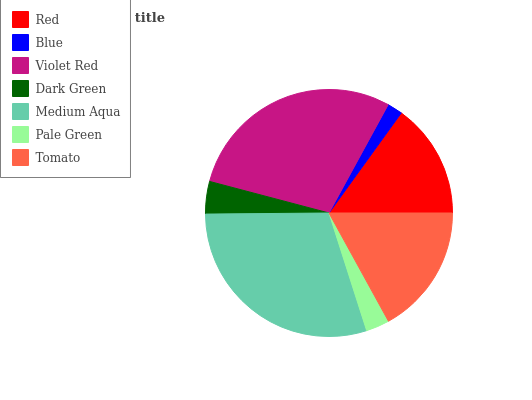Is Blue the minimum?
Answer yes or no. Yes. Is Medium Aqua the maximum?
Answer yes or no. Yes. Is Violet Red the minimum?
Answer yes or no. No. Is Violet Red the maximum?
Answer yes or no. No. Is Violet Red greater than Blue?
Answer yes or no. Yes. Is Blue less than Violet Red?
Answer yes or no. Yes. Is Blue greater than Violet Red?
Answer yes or no. No. Is Violet Red less than Blue?
Answer yes or no. No. Is Red the high median?
Answer yes or no. Yes. Is Red the low median?
Answer yes or no. Yes. Is Medium Aqua the high median?
Answer yes or no. No. Is Pale Green the low median?
Answer yes or no. No. 